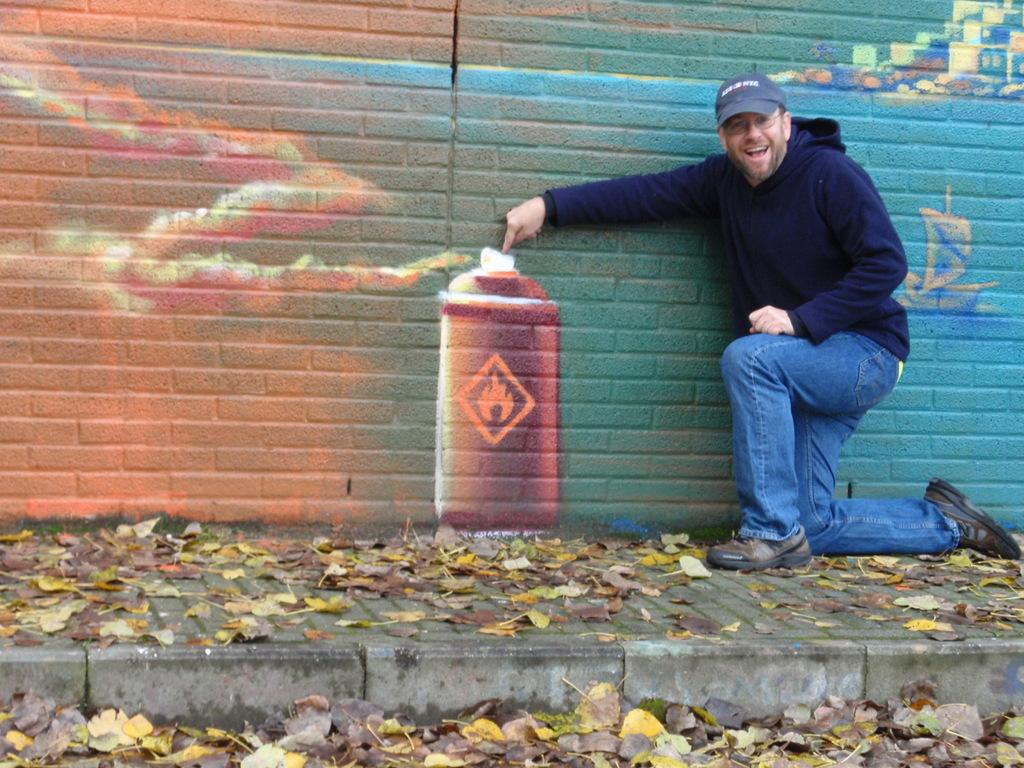What type of surface is visible in the image? There is a sidewalk in the image. Can you describe the person in the image? There is a person on the left corner of the image. What can be seen in the background of the image? There is a painting on the wall in the background of the image. What is the size of the person's mind in the image? There is no way to determine the size of the person's mind from the image, as it is not visible or measurable. 